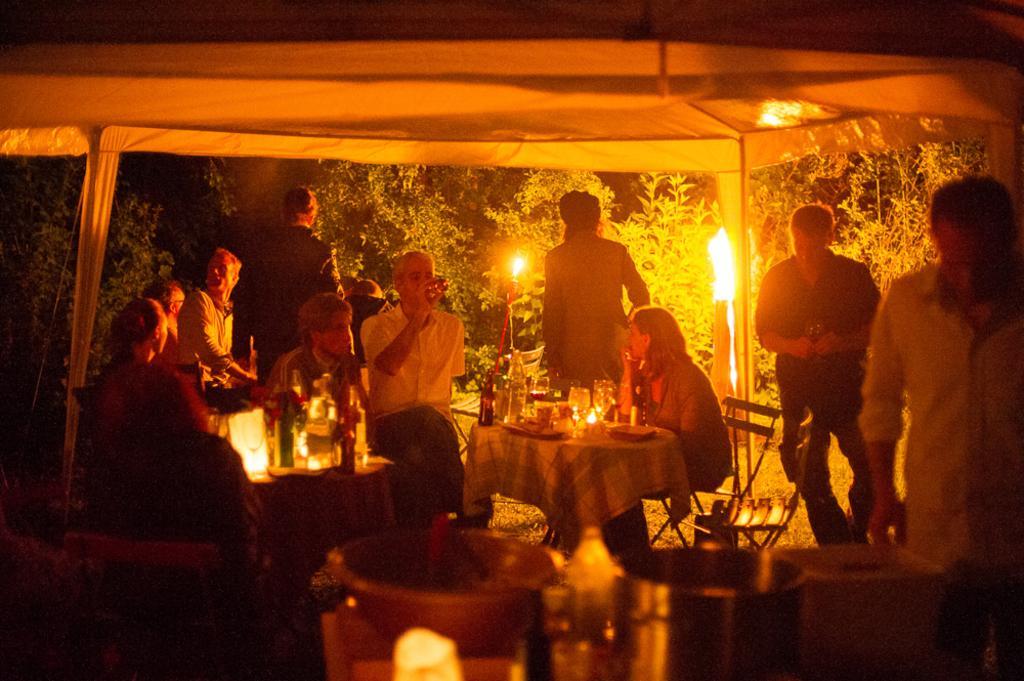Please provide a concise description of this image. In this picture there are some people sitting in the chairs around the tables on which some wine glasses, bottles and plates were placed under a tent. In the background there is a fire and some trees were here. 